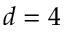Convert formula to latex. <formula><loc_0><loc_0><loc_500><loc_500>d = 4</formula> 